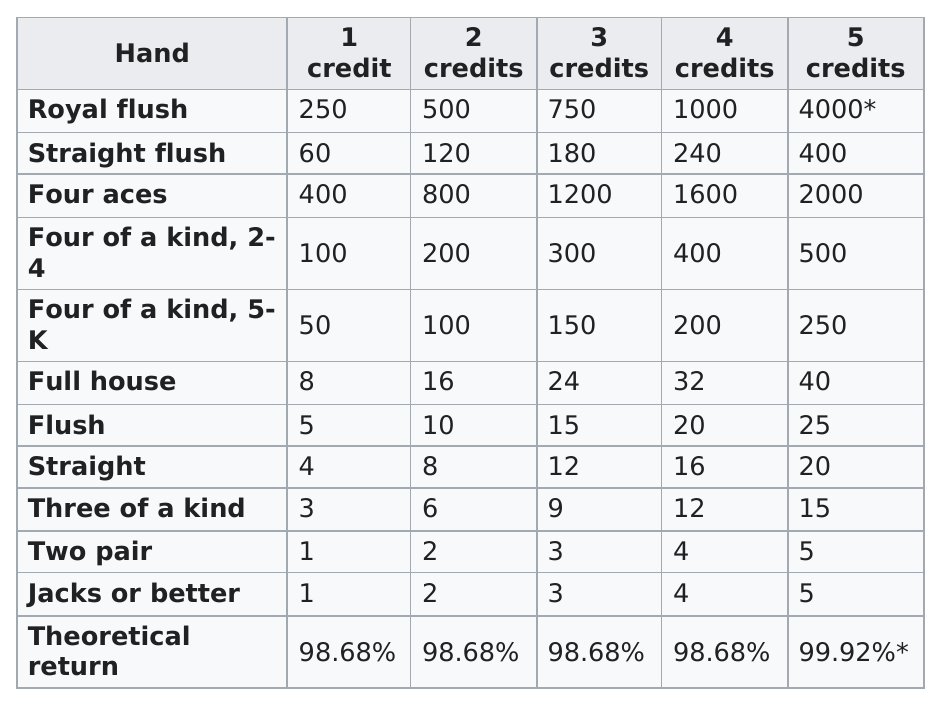Specify some key components in this picture. It is generally considered that a flush is a higher hand than a straight in poker. In a game where each set of four aces wins, the multiple of 400 that a winning set of four aces is multiplied by, varies. After winning with a full house on four credits, the payout would be 32. In order to win any credits at all, you must possess a pair of at least Jacks or better. The super ace card game requires players to discard two cards from their hand, and then draw new cards to replace them. The player who plays the highest ranked card, in this case the royal flush, wins the round. 